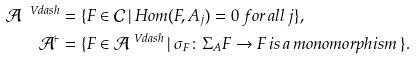<formula> <loc_0><loc_0><loc_500><loc_500>\mathcal { A } ^ { \ V d a s h } & = \{ F \in \mathcal { C } \, | \, H o m ( F , A _ { j } ) = 0 \, f o r \, a l l \, j \} , \\ \mathcal { A } ^ { \vdash } & = \{ F \in \mathcal { A } ^ { \ V d a s h } \, | \, \sigma _ { F } \colon \Sigma _ { A } F \to F \, i s \, a \, m o n o m o r p h i s m \, \} .</formula> 